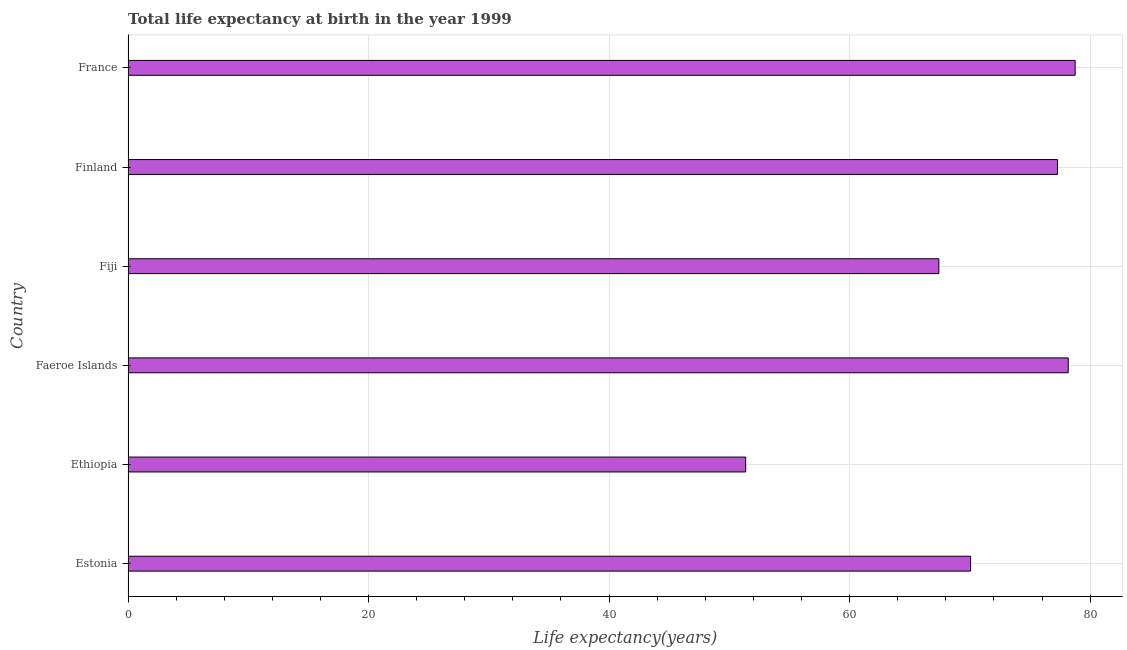Does the graph contain any zero values?
Offer a terse response. No. What is the title of the graph?
Provide a succinct answer. Total life expectancy at birth in the year 1999. What is the label or title of the X-axis?
Give a very brief answer. Life expectancy(years). What is the life expectancy at birth in Faeroe Islands?
Provide a succinct answer. 78.18. Across all countries, what is the maximum life expectancy at birth?
Provide a succinct answer. 78.76. Across all countries, what is the minimum life expectancy at birth?
Ensure brevity in your answer.  51.36. In which country was the life expectancy at birth maximum?
Your answer should be compact. France. In which country was the life expectancy at birth minimum?
Offer a terse response. Ethiopia. What is the sum of the life expectancy at birth?
Your answer should be compact. 423.07. What is the difference between the life expectancy at birth in Finland and France?
Provide a short and direct response. -1.47. What is the average life expectancy at birth per country?
Your answer should be compact. 70.51. What is the median life expectancy at birth?
Give a very brief answer. 73.68. What is the ratio of the life expectancy at birth in Ethiopia to that in Fiji?
Your answer should be very brief. 0.76. Is the life expectancy at birth in Fiji less than that in France?
Ensure brevity in your answer.  Yes. Is the difference between the life expectancy at birth in Faeroe Islands and Finland greater than the difference between any two countries?
Ensure brevity in your answer.  No. What is the difference between the highest and the second highest life expectancy at birth?
Offer a terse response. 0.58. What is the difference between the highest and the lowest life expectancy at birth?
Offer a terse response. 27.4. How many bars are there?
Your answer should be very brief. 6. What is the difference between two consecutive major ticks on the X-axis?
Provide a short and direct response. 20. Are the values on the major ticks of X-axis written in scientific E-notation?
Provide a short and direct response. No. What is the Life expectancy(years) of Estonia?
Ensure brevity in your answer.  70.06. What is the Life expectancy(years) of Ethiopia?
Provide a short and direct response. 51.36. What is the Life expectancy(years) of Faeroe Islands?
Make the answer very short. 78.18. What is the Life expectancy(years) in Fiji?
Offer a very short reply. 67.42. What is the Life expectancy(years) in Finland?
Give a very brief answer. 77.29. What is the Life expectancy(years) of France?
Make the answer very short. 78.76. What is the difference between the Life expectancy(years) in Estonia and Ethiopia?
Your response must be concise. 18.71. What is the difference between the Life expectancy(years) in Estonia and Faeroe Islands?
Ensure brevity in your answer.  -8.12. What is the difference between the Life expectancy(years) in Estonia and Fiji?
Give a very brief answer. 2.64. What is the difference between the Life expectancy(years) in Estonia and Finland?
Your answer should be compact. -7.23. What is the difference between the Life expectancy(years) in Estonia and France?
Give a very brief answer. -8.69. What is the difference between the Life expectancy(years) in Ethiopia and Faeroe Islands?
Your answer should be very brief. -26.82. What is the difference between the Life expectancy(years) in Ethiopia and Fiji?
Make the answer very short. -16.06. What is the difference between the Life expectancy(years) in Ethiopia and Finland?
Offer a very short reply. -25.93. What is the difference between the Life expectancy(years) in Ethiopia and France?
Your answer should be compact. -27.4. What is the difference between the Life expectancy(years) in Faeroe Islands and Fiji?
Offer a very short reply. 10.76. What is the difference between the Life expectancy(years) in Faeroe Islands and Finland?
Offer a very short reply. 0.89. What is the difference between the Life expectancy(years) in Faeroe Islands and France?
Ensure brevity in your answer.  -0.58. What is the difference between the Life expectancy(years) in Fiji and Finland?
Provide a short and direct response. -9.87. What is the difference between the Life expectancy(years) in Fiji and France?
Your response must be concise. -11.34. What is the difference between the Life expectancy(years) in Finland and France?
Provide a short and direct response. -1.46. What is the ratio of the Life expectancy(years) in Estonia to that in Ethiopia?
Your answer should be compact. 1.36. What is the ratio of the Life expectancy(years) in Estonia to that in Faeroe Islands?
Provide a succinct answer. 0.9. What is the ratio of the Life expectancy(years) in Estonia to that in Fiji?
Keep it short and to the point. 1.04. What is the ratio of the Life expectancy(years) in Estonia to that in Finland?
Your answer should be very brief. 0.91. What is the ratio of the Life expectancy(years) in Estonia to that in France?
Keep it short and to the point. 0.89. What is the ratio of the Life expectancy(years) in Ethiopia to that in Faeroe Islands?
Offer a very short reply. 0.66. What is the ratio of the Life expectancy(years) in Ethiopia to that in Fiji?
Provide a succinct answer. 0.76. What is the ratio of the Life expectancy(years) in Ethiopia to that in Finland?
Make the answer very short. 0.66. What is the ratio of the Life expectancy(years) in Ethiopia to that in France?
Offer a very short reply. 0.65. What is the ratio of the Life expectancy(years) in Faeroe Islands to that in Fiji?
Ensure brevity in your answer.  1.16. What is the ratio of the Life expectancy(years) in Faeroe Islands to that in Finland?
Ensure brevity in your answer.  1.01. What is the ratio of the Life expectancy(years) in Faeroe Islands to that in France?
Give a very brief answer. 0.99. What is the ratio of the Life expectancy(years) in Fiji to that in Finland?
Offer a terse response. 0.87. What is the ratio of the Life expectancy(years) in Fiji to that in France?
Offer a terse response. 0.86. What is the ratio of the Life expectancy(years) in Finland to that in France?
Your answer should be compact. 0.98. 